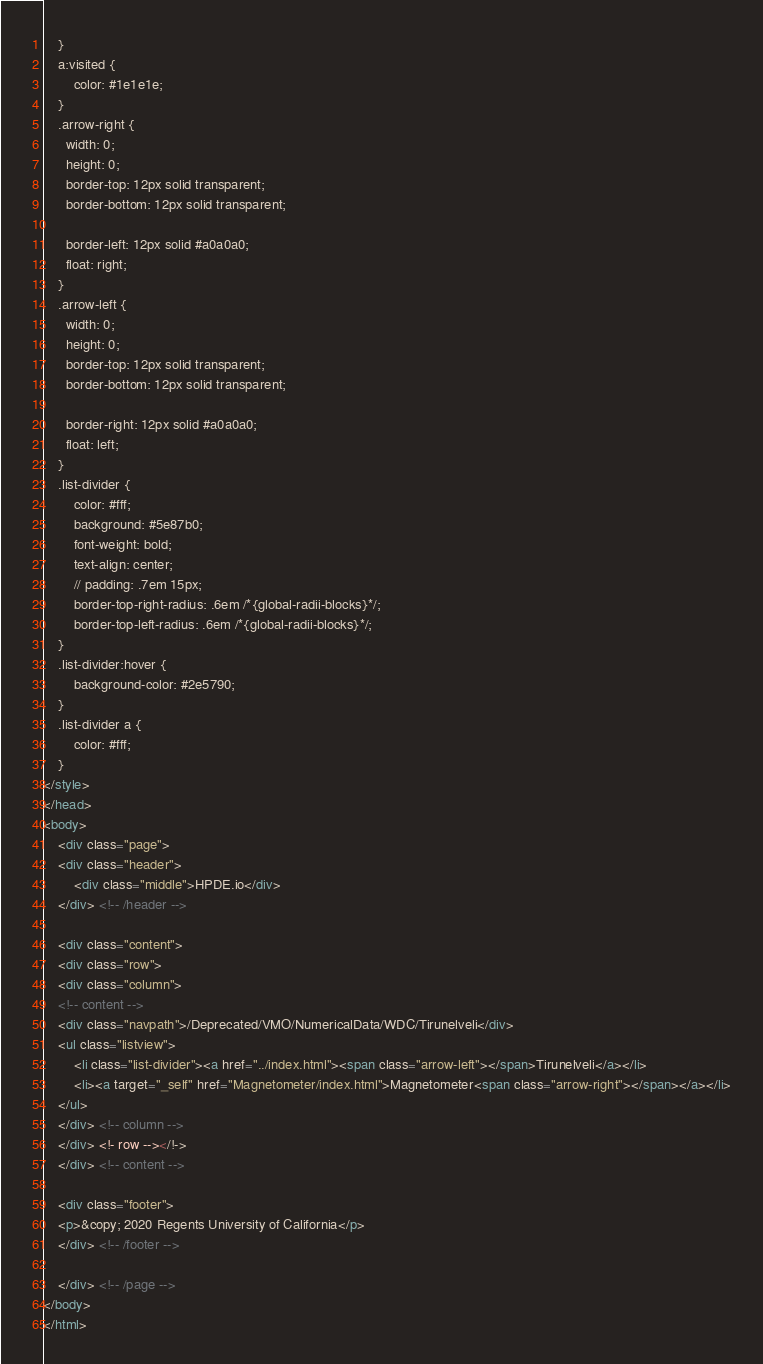Convert code to text. <code><loc_0><loc_0><loc_500><loc_500><_HTML_>	}
	a:visited {
		color: #1e1e1e;
	}
	.arrow-right {
	  width: 0; 
	  height: 0; 
	  border-top: 12px solid transparent;
	  border-bottom: 12px solid transparent;
	  
	  border-left: 12px solid #a0a0a0;
	  float: right;
	}
	.arrow-left {
	  width: 0; 
	  height: 0; 
	  border-top: 12px solid transparent;
	  border-bottom: 12px solid transparent;
	  
	  border-right: 12px solid #a0a0a0;
	  float: left;
	}
	.list-divider {
		color: #fff;
		background: #5e87b0;
		font-weight: bold;
		text-align: center;
		// padding: .7em 15px;
		border-top-right-radius: .6em /*{global-radii-blocks}*/;
		border-top-left-radius: .6em /*{global-radii-blocks}*/;
	}
	.list-divider:hover {
		background-color: #2e5790;
	}
	.list-divider a {
		color: #fff;
	}
</style>
</head>
<body>
	<div class="page">
	<div class="header">
		<div class="middle">HPDE.io</div>
	</div> <!-- /header -->
	
	<div class="content">
	<div class="row">
	<div class="column">
	<!-- content -->
	<div class="navpath">/Deprecated/VMO/NumericalData/WDC/Tirunelveli</div>
	<ul class="listview">
		<li class="list-divider"><a href="../index.html"><span class="arrow-left"></span>Tirunelveli</a></li>
		<li><a target="_self" href="Magnetometer/index.html">Magnetometer<span class="arrow-right"></span></a></li>
	</ul>
	</div> <!-- column -->
	</div> <!- row --></!->
	</div> <!-- content -->
	
	<div class="footer">
	<p>&copy; 2020 Regents University of California</p>
	</div> <!-- /footer -->
	
	</div> <!-- /page -->
</body>
</html></code> 